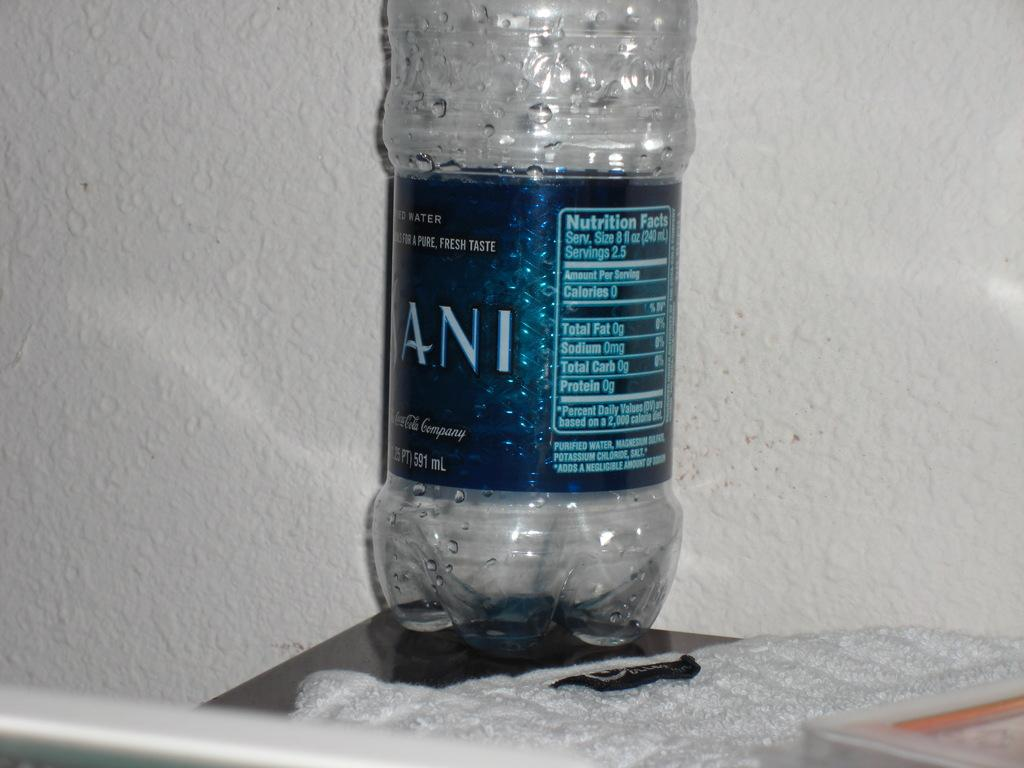<image>
Present a compact description of the photo's key features. An empty plastic bottle with the brand dasani on its label. 